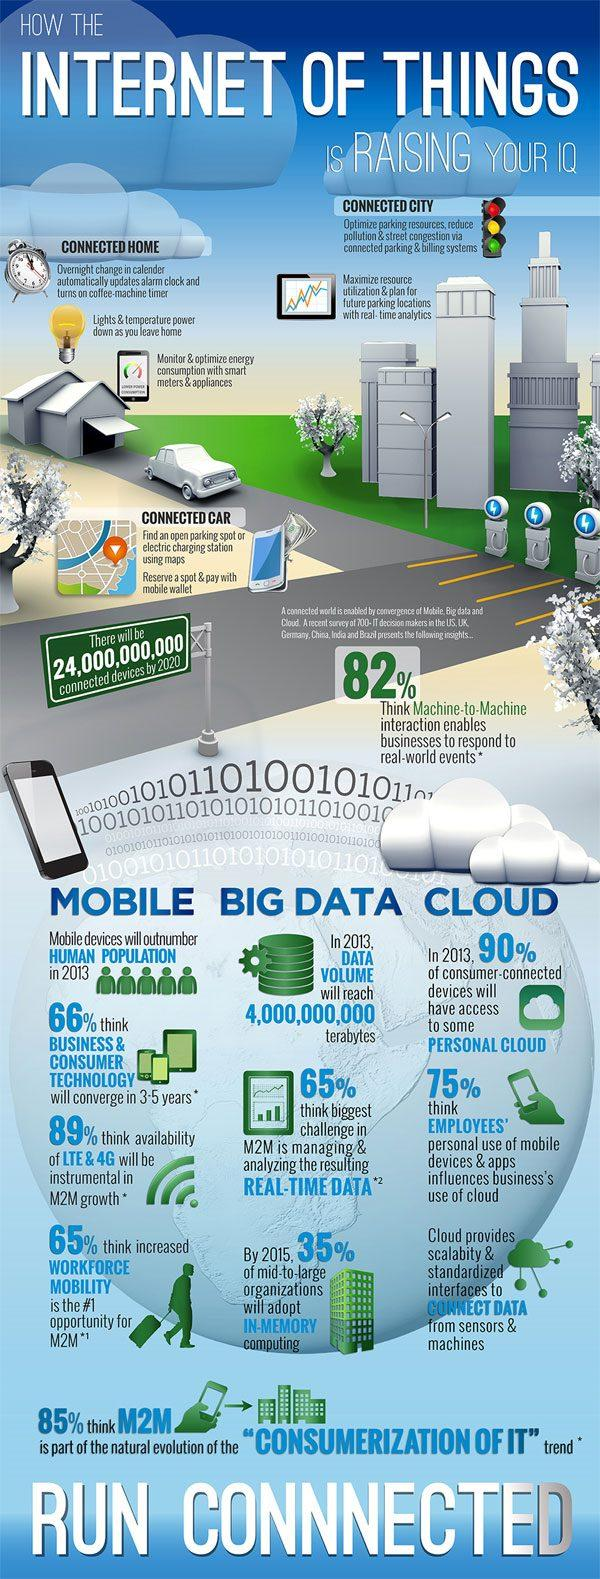Outline some significant characteristics in this image. In 2013, the estimated data volume was approximately 4,000,000,000 terabytes. According to a survey of IT decision makers, managing and analyzing real-time data from M2M (machine-to-machine) systems was identified as the biggest challenge facing their organizations. Specifically, 65% of survey respondents felt that this was a significant challenge. In 2013, it is predicted that 90% of consumer connected devices will have access to some form of personal cloud. According to a survey of IT decision makers, a staggering 89% believe that the availability of LTE and 4G networks will play a crucial role in the growth of M2M (machine-to-machine) communication. By 2015, approximately 35% of mid-to-large organizations are expected to adopt in-memory computing. 